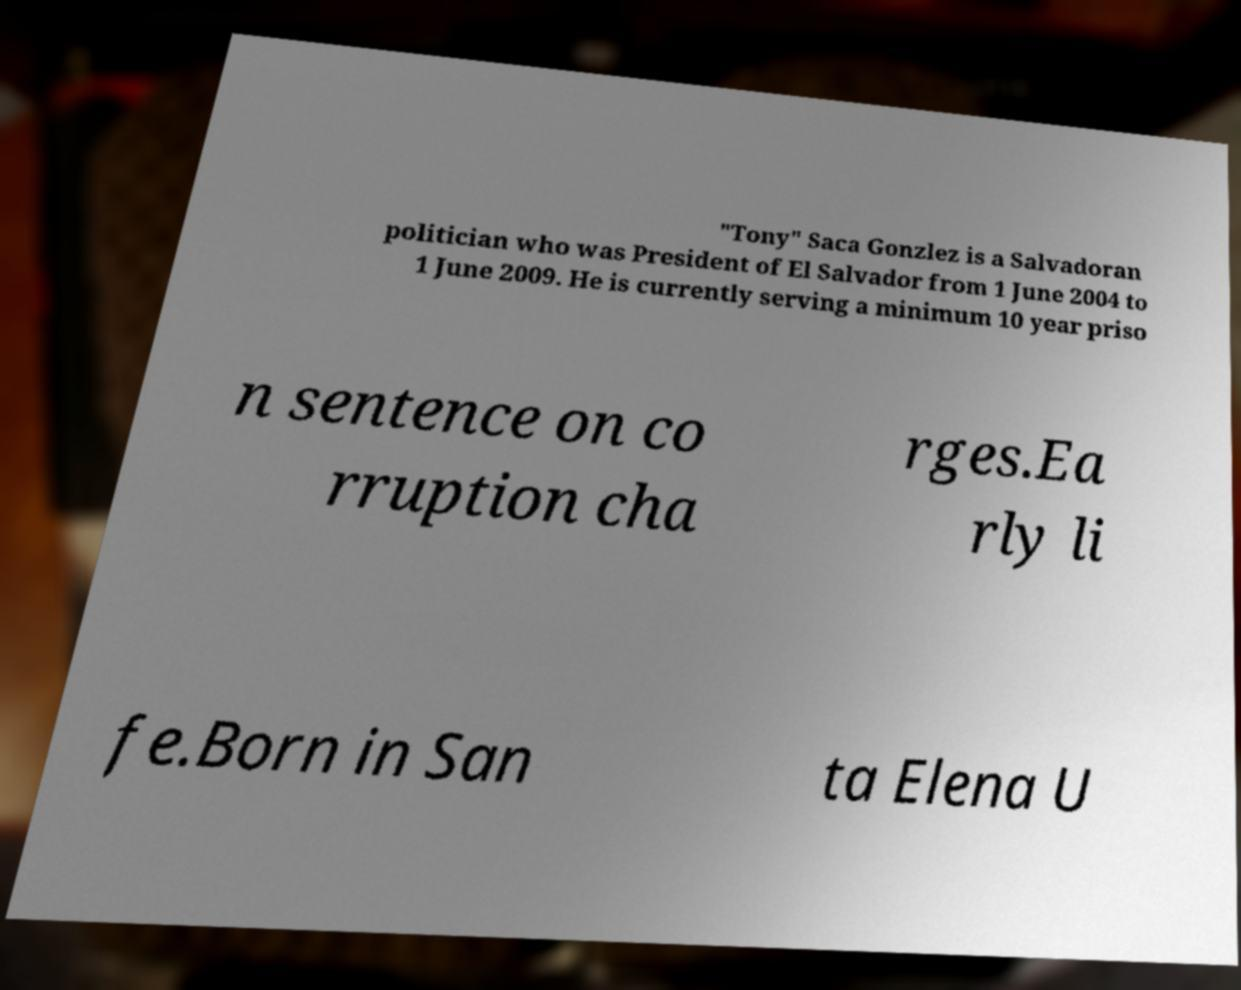Please identify and transcribe the text found in this image. "Tony" Saca Gonzlez is a Salvadoran politician who was President of El Salvador from 1 June 2004 to 1 June 2009. He is currently serving a minimum 10 year priso n sentence on co rruption cha rges.Ea rly li fe.Born in San ta Elena U 